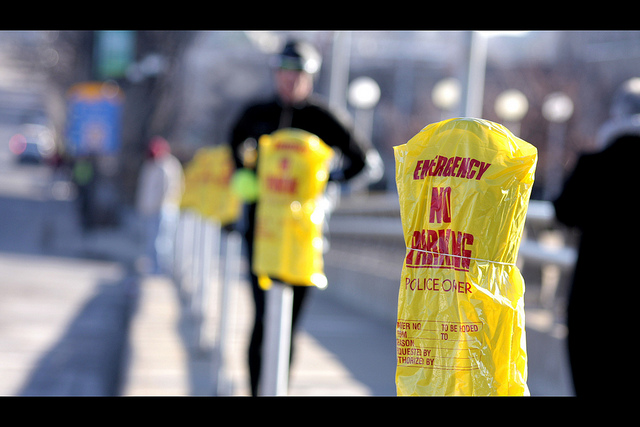<image>Who is the man in the photo? It is unknown who the man in the photo is. He could be a jogger, policeman, or a man in black. Who is the man in the photo? I don't know who the man in the photo is. It could be a police officer, a man in black, or a jogger. 